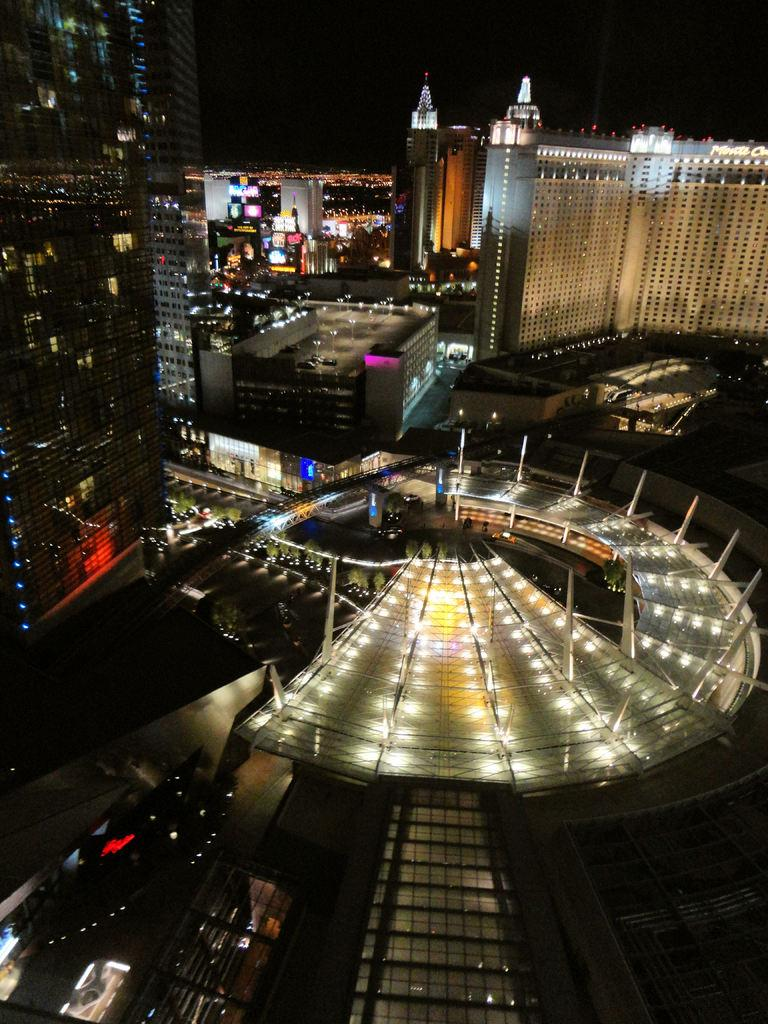What is the main subject of the image? The main subject of the image is many buildings. What feature do the buildings have? The buildings have lights. What can be observed about the background of the image? The background of the image is dark. What type of chin can be seen on the building in the image? There is no chin present on any of the buildings in the image. What kind of shade is being used to cover the windows of the buildings in the image? There is no mention of shades or any window coverings in the image. 